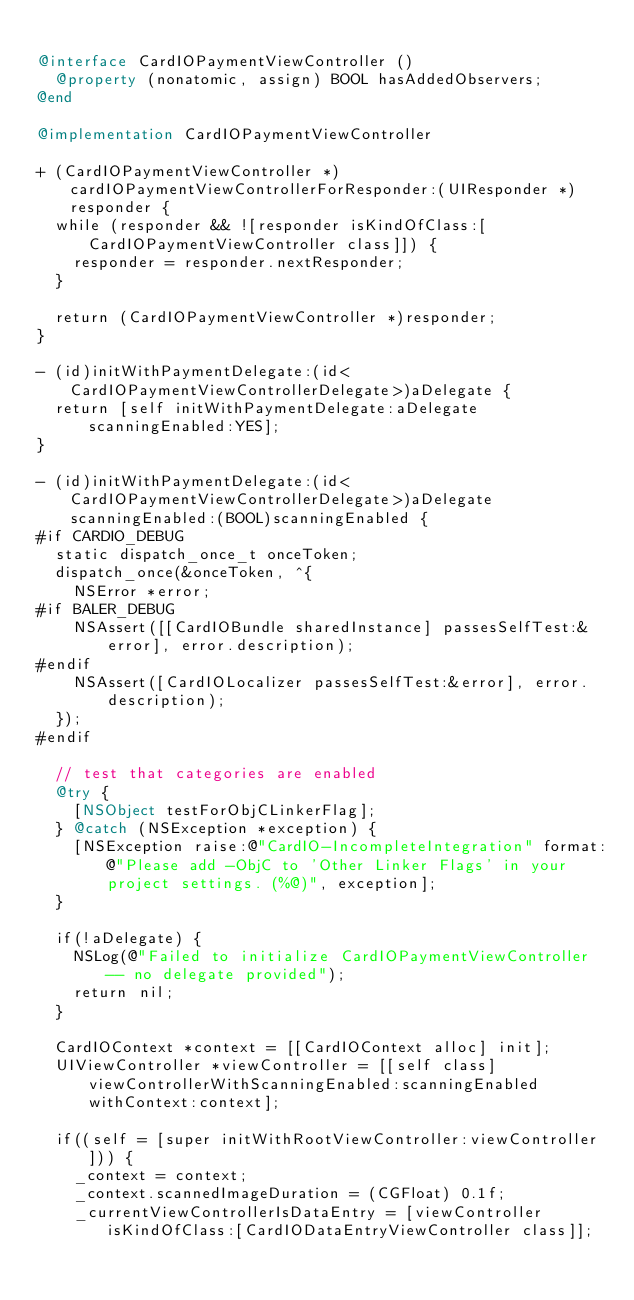<code> <loc_0><loc_0><loc_500><loc_500><_ObjectiveC_>
@interface CardIOPaymentViewController ()
  @property (nonatomic, assign) BOOL hasAddedObservers;
@end

@implementation CardIOPaymentViewController

+ (CardIOPaymentViewController *)cardIOPaymentViewControllerForResponder:(UIResponder *)responder {
  while (responder && ![responder isKindOfClass:[CardIOPaymentViewController class]]) {
    responder = responder.nextResponder;
  }
  
  return (CardIOPaymentViewController *)responder;
}

- (id)initWithPaymentDelegate:(id<CardIOPaymentViewControllerDelegate>)aDelegate {
  return [self initWithPaymentDelegate:aDelegate scanningEnabled:YES];
}

- (id)initWithPaymentDelegate:(id<CardIOPaymentViewControllerDelegate>)aDelegate scanningEnabled:(BOOL)scanningEnabled {
#if CARDIO_DEBUG
  static dispatch_once_t onceToken;
  dispatch_once(&onceToken, ^{
    NSError *error;
#if BALER_DEBUG
    NSAssert([[CardIOBundle sharedInstance] passesSelfTest:&error], error.description);
#endif
    NSAssert([CardIOLocalizer passesSelfTest:&error], error.description);
  });
#endif

  // test that categories are enabled
  @try {
    [NSObject testForObjCLinkerFlag];
  } @catch (NSException *exception) {
    [NSException raise:@"CardIO-IncompleteIntegration" format:@"Please add -ObjC to 'Other Linker Flags' in your project settings. (%@)", exception];
  }
  
  if(!aDelegate) {
    NSLog(@"Failed to initialize CardIOPaymentViewController -- no delegate provided");
    return nil;
  }

  CardIOContext *context = [[CardIOContext alloc] init];
  UIViewController *viewController = [[self class] viewControllerWithScanningEnabled:scanningEnabled withContext:context];

  if((self = [super initWithRootViewController:viewController])) {
    _context = context;
    _context.scannedImageDuration = (CGFloat) 0.1f;
    _currentViewControllerIsDataEntry = [viewController isKindOfClass:[CardIODataEntryViewController class]];</code> 